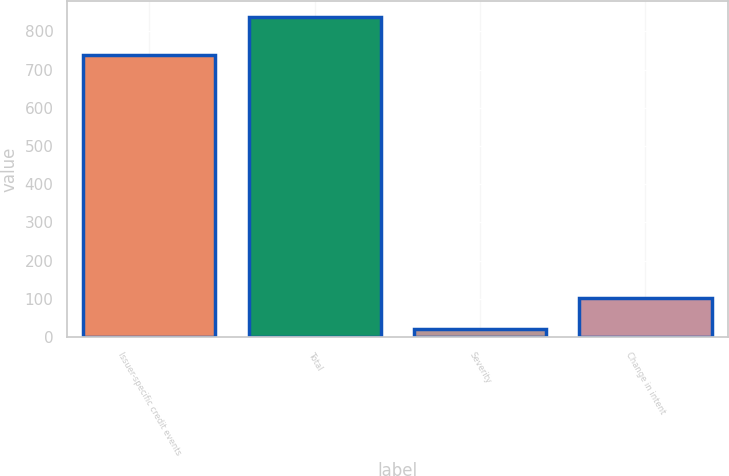Convert chart to OTSL. <chart><loc_0><loc_0><loc_500><loc_500><bar_chart><fcel>Issuer-specific credit events<fcel>Total<fcel>Severity<fcel>Change in intent<nl><fcel>739<fcel>838<fcel>21<fcel>102.7<nl></chart> 